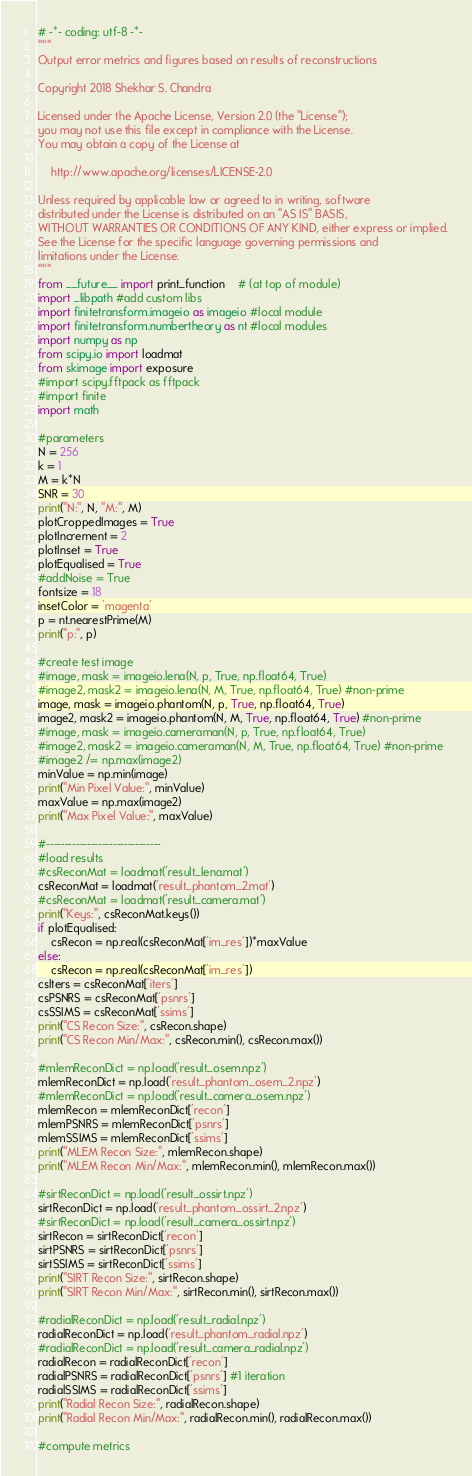Convert code to text. <code><loc_0><loc_0><loc_500><loc_500><_Python_># -*- coding: utf-8 -*-
"""
Output error metrics and figures based on results of reconstructions

Copyright 2018 Shekhar S. Chandra

Licensed under the Apache License, Version 2.0 (the "License");
you may not use this file except in compliance with the License.
You may obtain a copy of the License at

    http://www.apache.org/licenses/LICENSE-2.0

Unless required by applicable law or agreed to in writing, software
distributed under the License is distributed on an "AS IS" BASIS,
WITHOUT WARRANTIES OR CONDITIONS OF ANY KIND, either express or implied.
See the License for the specific language governing permissions and
limitations under the License.
"""
from __future__ import print_function    # (at top of module)
import _libpath #add custom libs
import finitetransform.imageio as imageio #local module
import finitetransform.numbertheory as nt #local modules
import numpy as np
from scipy.io import loadmat
from skimage import exposure
#import scipy.fftpack as fftpack
#import finite
import math

#parameters
N = 256
k = 1
M = k*N
SNR = 30
print("N:", N, "M:", M)
plotCroppedImages = True
plotIncrement = 2
plotInset = True
plotEqualised = True 
#addNoise = True
fontsize = 18
insetColor = 'magenta'
p = nt.nearestPrime(M)
print("p:", p)

#create test image
#image, mask = imageio.lena(N, p, True, np.float64, True)
#image2, mask2 = imageio.lena(N, M, True, np.float64, True) #non-prime
image, mask = imageio.phantom(N, p, True, np.float64, True)
image2, mask2 = imageio.phantom(N, M, True, np.float64, True) #non-prime
#image, mask = imageio.cameraman(N, p, True, np.float64, True)
#image2, mask2 = imageio.cameraman(N, M, True, np.float64, True) #non-prime
#image2 /= np.max(image2)
minValue = np.min(image)
print("Min Pixel Value:", minValue)
maxValue = np.max(image2)
print("Max Pixel Value:", maxValue)

#-------------------------------
#load results
#csReconMat = loadmat('result_lena.mat')
csReconMat = loadmat('result_phantom_2.mat')
#csReconMat = loadmat('result_camera.mat')
print("Keys:", csReconMat.keys())
if plotEqualised:
    csRecon = np.real(csReconMat['im_res'])*maxValue
else:
    csRecon = np.real(csReconMat['im_res'])
csIters = csReconMat['iters']
csPSNRS = csReconMat['psnrs']
csSSIMS = csReconMat['ssims']
print("CS Recon Size:", csRecon.shape)
print("CS Recon Min/Max:", csRecon.min(), csRecon.max())

#mlemReconDict = np.load('result_osem.npz')
mlemReconDict = np.load('result_phantom_osem_2.npz')
#mlemReconDict = np.load('result_camera_osem.npz')
mlemRecon = mlemReconDict['recon']
mlemPSNRS = mlemReconDict['psnrs']
mlemSSIMS = mlemReconDict['ssims']
print("MLEM Recon Size:", mlemRecon.shape)
print("MLEM Recon Min/Max:", mlemRecon.min(), mlemRecon.max())

#sirtReconDict = np.load('result_ossirt.npz')
sirtReconDict = np.load('result_phantom_ossirt_2.npz')
#sirtReconDict = np.load('result_camera_ossirt.npz')
sirtRecon = sirtReconDict['recon']
sirtPSNRS = sirtReconDict['psnrs']
sirtSSIMS = sirtReconDict['ssims']
print("SIRT Recon Size:", sirtRecon.shape)
print("SIRT Recon Min/Max:", sirtRecon.min(), sirtRecon.max())

#radialReconDict = np.load('result_radial.npz')
radialReconDict = np.load('result_phantom_radial.npz')
#radialReconDict = np.load('result_camera_radial.npz')
radialRecon = radialReconDict['recon']
radialPSNRS = radialReconDict['psnrs'] #1 iteration
radialSSIMS = radialReconDict['ssims']
print("Radial Recon Size:", radialRecon.shape)
print("Radial Recon Min/Max:", radialRecon.min(), radialRecon.max())

#compute metrics</code> 